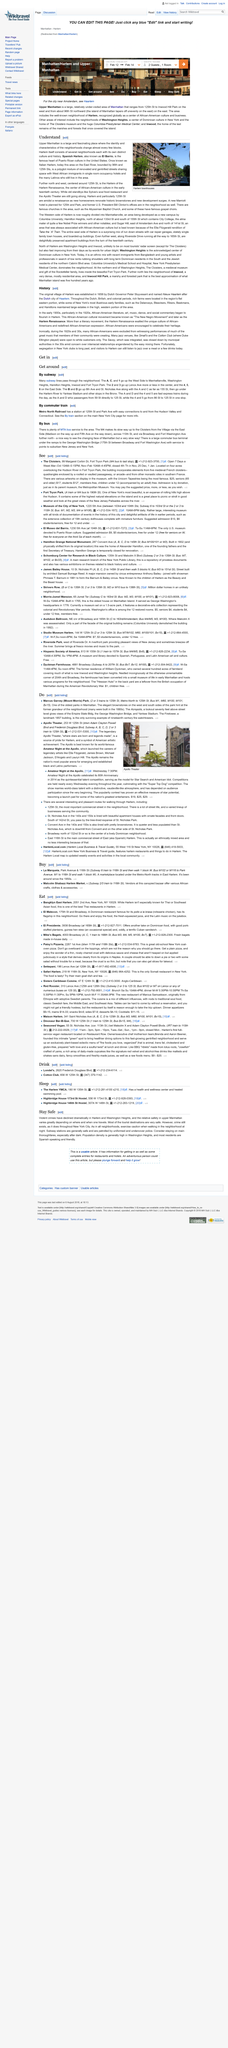Draw attention to some important aspects in this diagram. There are two methods of transportation that are available for getting around New York City, namely the subway and the commuter train. Upper Manhattan, formerly known as Italian Harlem, was once renowned for its vibrant Italian American community. The journey from 86th Street to 125th Street on the 4 and 5 trains takes approximately 3 stops. The 2 and 3 subways travel up the streets, with the 2 subway going towards Lenox Avenue. This area is located near the East River. 